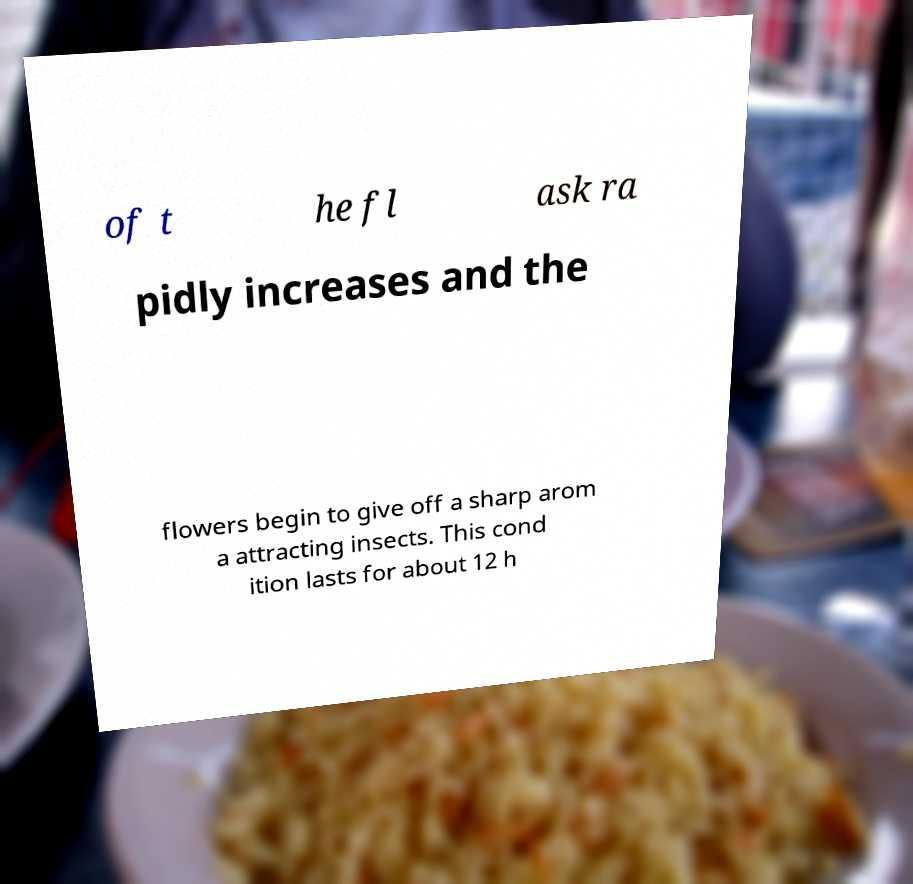Could you assist in decoding the text presented in this image and type it out clearly? of t he fl ask ra pidly increases and the flowers begin to give off a sharp arom a attracting insects. This cond ition lasts for about 12 h 